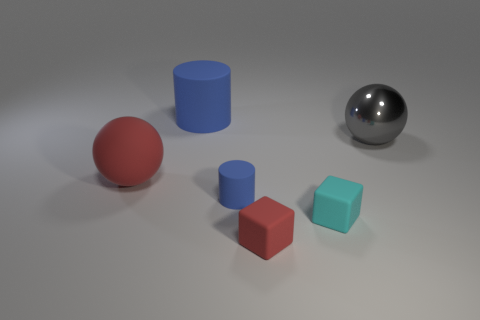Is there a big blue sphere made of the same material as the red cube?
Ensure brevity in your answer.  No. There is a tiny matte block that is behind the rubber thing in front of the cyan rubber cube; is there a big sphere in front of it?
Give a very brief answer. No. There is a red cube; are there any red things to the left of it?
Provide a succinct answer. Yes. Is there another large metal thing that has the same color as the shiny thing?
Keep it short and to the point. No. How many tiny objects are red balls or gray metal things?
Your answer should be very brief. 0. Is the material of the red object on the left side of the large blue cylinder the same as the large cylinder?
Keep it short and to the point. Yes. There is a large gray metal thing in front of the cylinder behind the big sphere in front of the gray metallic ball; what shape is it?
Offer a very short reply. Sphere. How many blue objects are big rubber spheres or big matte cylinders?
Offer a very short reply. 1. Is the number of large gray metallic spheres that are on the right side of the gray ball the same as the number of red rubber balls on the left side of the tiny blue thing?
Your answer should be very brief. No. Is the shape of the red object right of the rubber sphere the same as the small cyan object on the right side of the tiny blue cylinder?
Provide a short and direct response. Yes. 